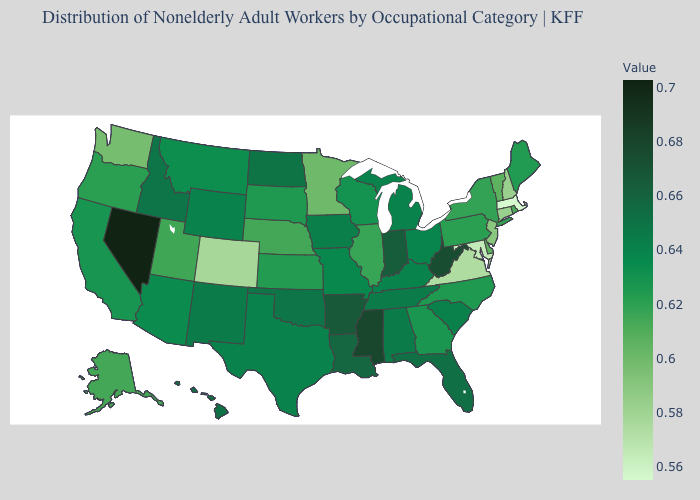Which states have the lowest value in the USA?
Short answer required. Massachusetts. Does the map have missing data?
Concise answer only. No. Which states hav the highest value in the South?
Short answer required. Mississippi. 